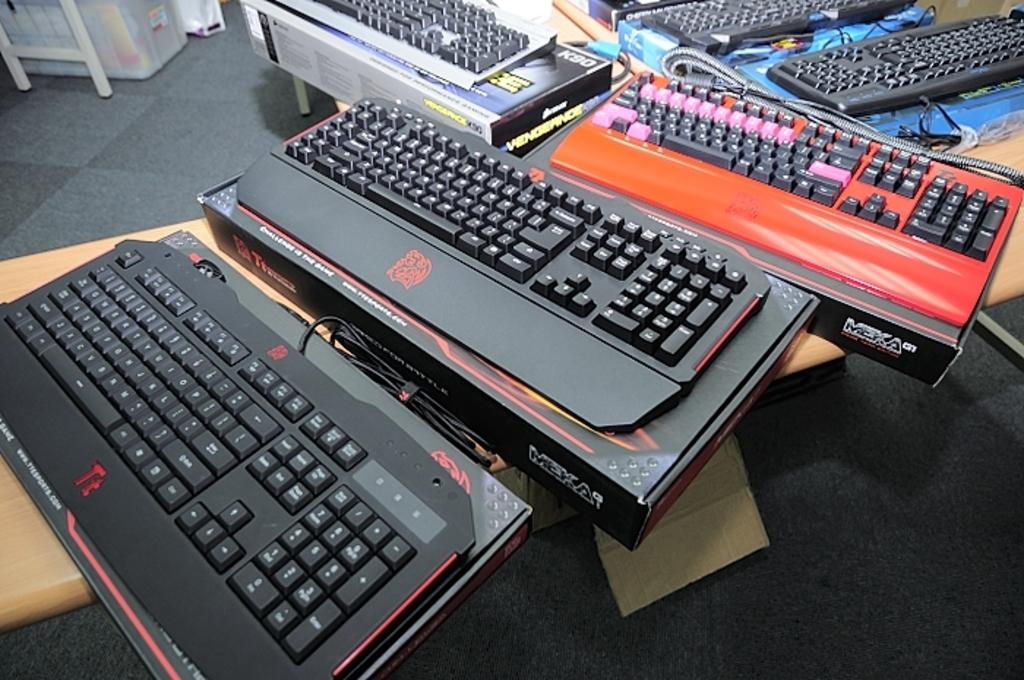<image>
Provide a brief description of the given image. Several keyboards on a desk, most are gaming keyboards that are Meka brand. 